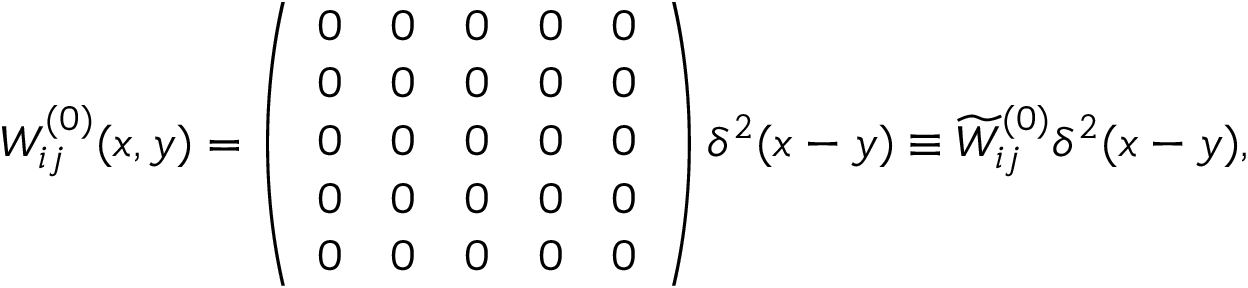<formula> <loc_0><loc_0><loc_500><loc_500>W _ { i j } ^ { ( 0 ) } ( x , y ) = \left ( \begin{array} { c c c c c } { 0 } & { 0 } & { 0 } & { 0 } & { 0 } \\ { 0 } & { 0 } & { 0 } & { 0 } & { 0 } \\ { 0 } & { 0 } & { 0 } & { 0 } & { 0 } \\ { 0 } & { 0 } & { 0 } & { 0 } & { 0 } \\ { 0 } & { 0 } & { 0 } & { 0 } & { 0 } \end{array} \right ) \delta ^ { 2 } ( x - y ) \equiv \widetilde { W } _ { i j } ^ { ( 0 ) } \delta ^ { 2 } ( x - y ) ,</formula> 